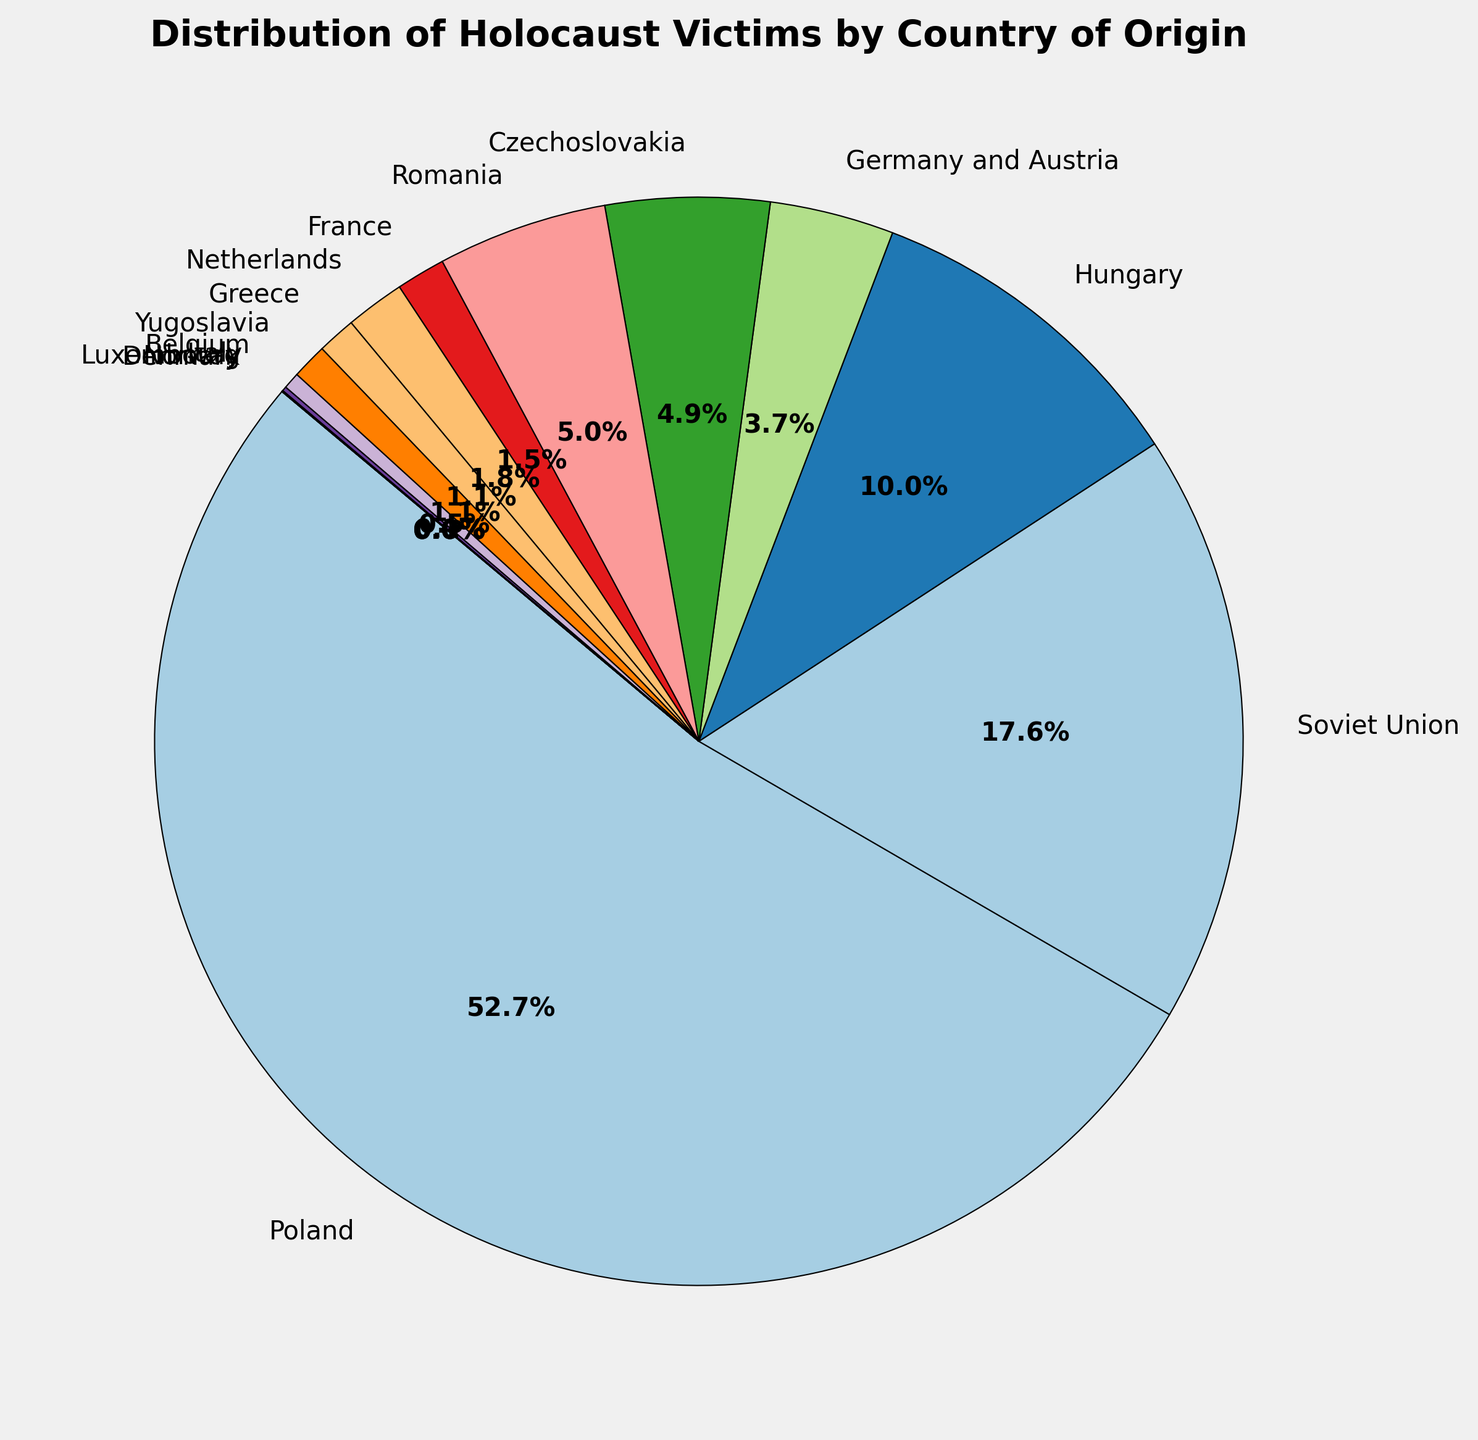Which country has the highest number of Holocaust victims? The largest wedge in the pie chart corresponds to Poland, indicating it has the highest number of Holocaust victims.
Answer: Poland What percentage of Holocaust victims were from Poland? By looking at the data on the pie chart, the segment labeled "Poland" shows a percentage.
Answer: 48.9% Which countries have less than 0.1% of Holocaust victims? Observing the pie chart, the smallest segments represent Denmark and Norway. Their labels indicate they have less than 0.1% of the total victims.
Answer: Denmark, Norway How many more victims were there from the Soviet Union compared to Hungary? The data shows Soviet Union has 1,000,000 victims and Hungary has 569,000. The difference is 1,000,000 - 569,000.
Answer: 431,000 What is the combined percentage of Holocaust victims from France and the Netherlands? Checking the pie chart, France accounts for 1.4% and the Netherlands for 1.6%. Adding these percentages gives 1.4% + 1.6%.
Answer: 3% Which countries have a similar percentage of Holocaust victims, each close to 4.7%? The pie chart shows that both Czechoslovakia and Romania have nearly 4.7% each.
Answer: Czechoslovakia, Romania What percentage of Holocaust victims came from countries other than Poland and the Soviet Union? The pie chart indicates Poland (48.9%) and the Soviet Union (16.3%). Summing these gives 65.2%. Subtract from 100% to get victims from other countries: 100% - 65.2%.
Answer: 34.8% Comparatively, did Italy or Luxembourg have a higher number of Holocaust victims? Observing the pie chart, Italy has a larger segment relative to Luxembourg.
Answer: Italy How does the number of victims from Greece compare to that of the Netherlands? Both Greece and the Netherlands are labeled in the pie chart: Greece has 65,000 victims, while the Netherlands has 100,000. Therefore, the Netherlands had more victims.
Answer: Netherlands What is the total percentage of Holocaust victims from Hungary and Germany and Austria combined? Hungary's segment shows 9.8% and Germany and Austria's shows 3.6%. Adding these gives 9.8% + 3.6%.
Answer: 13.4% 